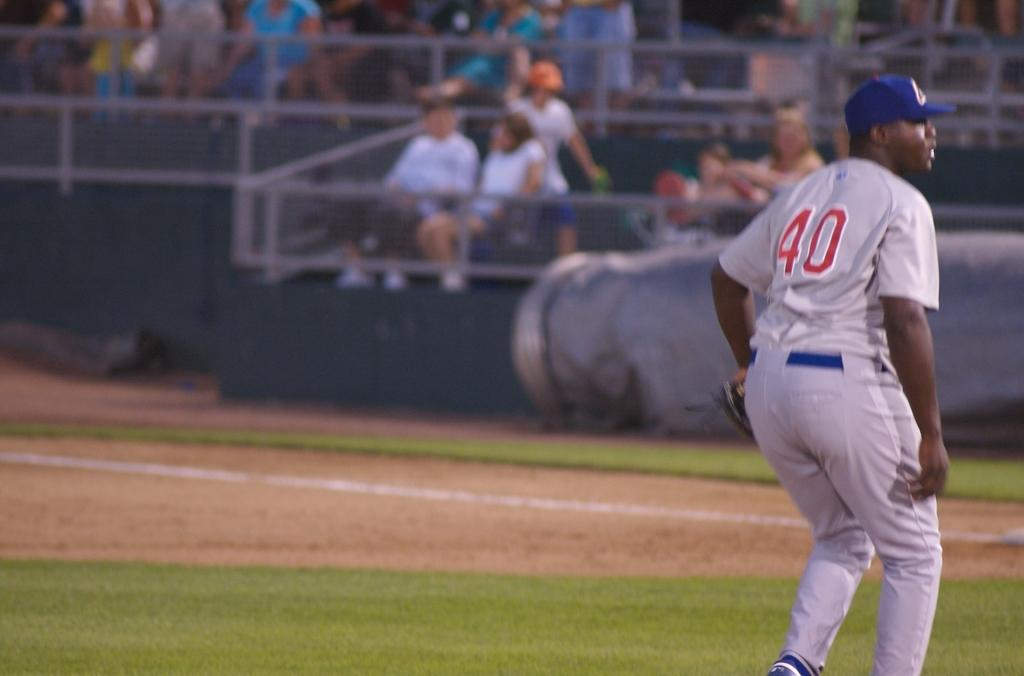<image>
Provide a brief description of the given image. Baseball player wearing a jersey that has the number 40. 